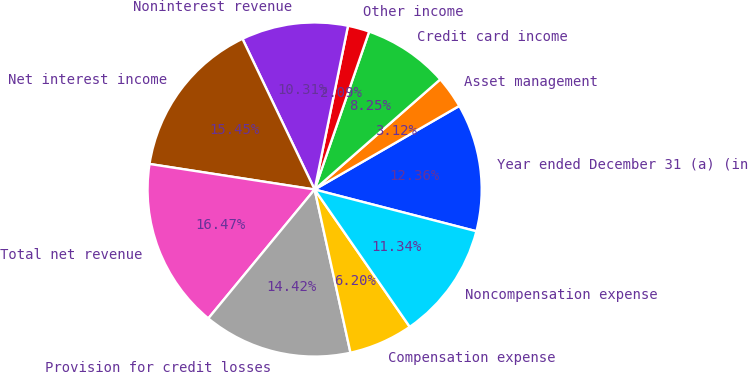<chart> <loc_0><loc_0><loc_500><loc_500><pie_chart><fcel>Year ended December 31 (a) (in<fcel>Asset management<fcel>Credit card income<fcel>Other income<fcel>Noninterest revenue<fcel>Net interest income<fcel>Total net revenue<fcel>Provision for credit losses<fcel>Compensation expense<fcel>Noncompensation expense<nl><fcel>12.36%<fcel>3.12%<fcel>8.25%<fcel>2.09%<fcel>10.31%<fcel>15.45%<fcel>16.47%<fcel>14.42%<fcel>6.2%<fcel>11.34%<nl></chart> 